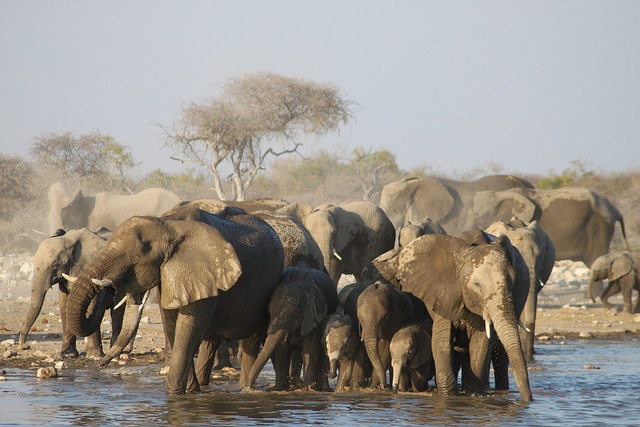Describe the objects in this image and their specific colors. I can see elephant in lightgray, black, gray, and tan tones, elephant in lightgray, gray, black, and tan tones, elephant in lightgray, black, tan, and gray tones, elephant in lightgray, black, and gray tones, and elephant in lightgray, gray, and tan tones in this image. 